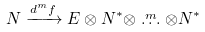<formula> <loc_0><loc_0><loc_500><loc_500>N & \xrightarrow { d ^ { m } f } E \otimes N ^ { * } \otimes \stackrel { m } { \dots } \otimes N ^ { * }</formula> 